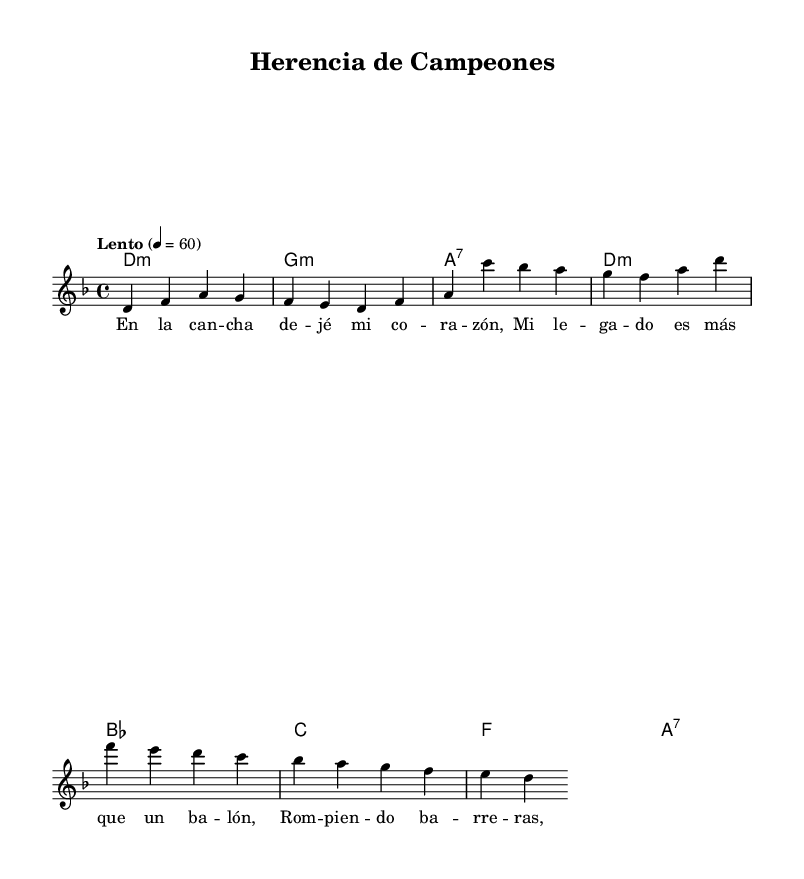What is the key signature of this music? The key signature is determined by the presence of flat or sharp notes in the piece. In this case, the music is in D minor, which has one flat (Bb).
Answer: D minor What is the time signature of this music? The time signature is found at the beginning of the piece, indicating how many beats per measure and what note value gets one beat. Here, the time signature is 4/4, meaning there are four beats in each measure and a quarter note receives one beat.
Answer: 4/4 What is the tempo marking of this music? The tempo marking is indicated at the beginning of the piece, specifying the speed of the music. Here, it states "Lento" and a tempo of 60 beats per minute, which is a slow tempo.
Answer: Lento What are the first two notes of the melody? The melody starts with the notes D and F, as seen at the beginning of the melody section in the staff.
Answer: D, F What are the lyrics of the first line? The lyrics are provided in the lyrics section aligned with the melody. The first line reads "En la canción de jé mi corazón," which captures the emotional essence of the piece.
Answer: En la canción de jé mi corazón Which chord accompanies the last measure? To find the chord accompanying the last measure, we look at the harmonies indicated in the chord mode at the bottom. The final chord listed corresponds to the last measure and is A7.
Answer: A7 How many measures are in the melody? Counting the melody notes and their corresponding rests, we find that there are four measures total, as indicated by the alignments of notes and spaces in the sheet music.
Answer: Four 